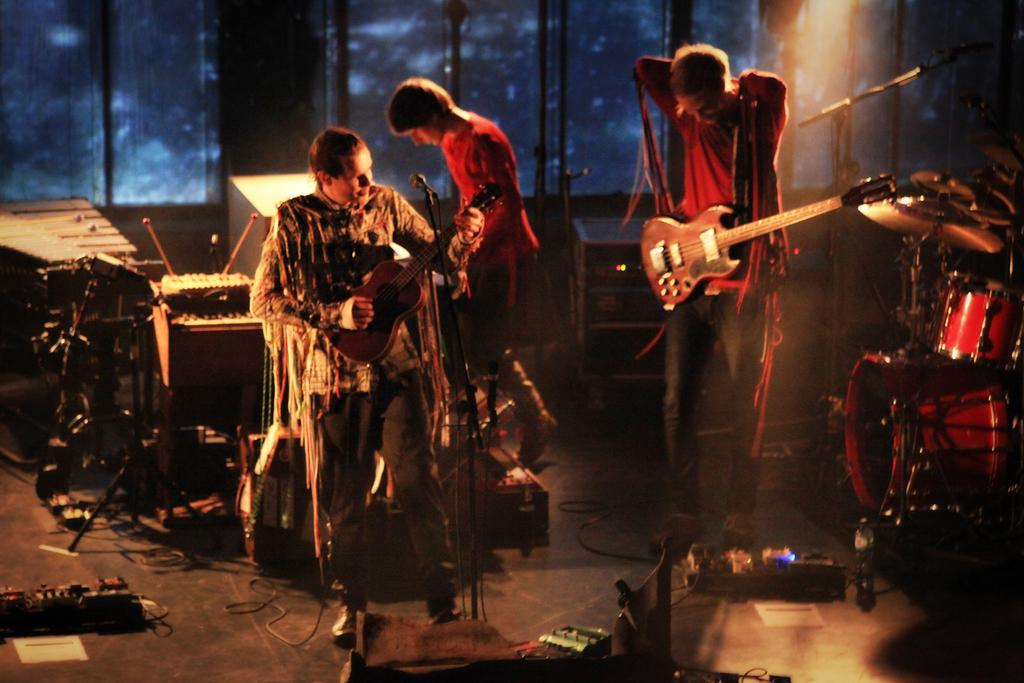How many people are present in the image? There are people standing in the image. What are two of the people holding? Two people are holding guitars. What equipment is visible in the image that is commonly used in music performances? There is a microphone (mic) and a drum set in the image. What type of land can be seen in the background of the image? There is no land visible in the image, as it primarily features people and musical equipment. What tools might a carpenter use that are not present in the image? There are no carpentry tools present in the image, as it focuses on people and musical equipment. 